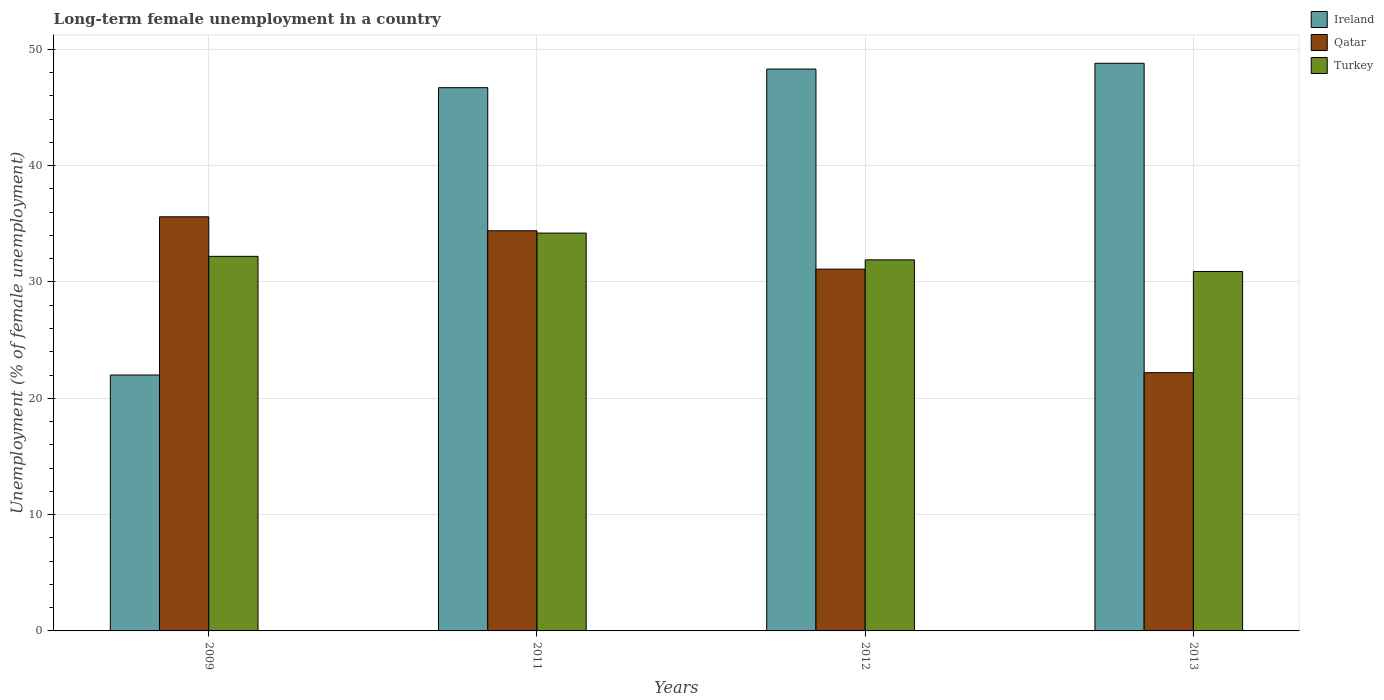How many different coloured bars are there?
Offer a terse response. 3. Are the number of bars on each tick of the X-axis equal?
Ensure brevity in your answer.  Yes. How many bars are there on the 1st tick from the left?
Offer a very short reply. 3. What is the label of the 1st group of bars from the left?
Ensure brevity in your answer.  2009. What is the percentage of long-term unemployed female population in Ireland in 2013?
Offer a very short reply. 48.8. Across all years, what is the maximum percentage of long-term unemployed female population in Qatar?
Ensure brevity in your answer.  35.6. Across all years, what is the minimum percentage of long-term unemployed female population in Qatar?
Offer a very short reply. 22.2. What is the total percentage of long-term unemployed female population in Ireland in the graph?
Offer a very short reply. 165.8. What is the difference between the percentage of long-term unemployed female population in Turkey in 2012 and that in 2013?
Offer a terse response. 1. What is the difference between the percentage of long-term unemployed female population in Turkey in 2009 and the percentage of long-term unemployed female population in Ireland in 2013?
Ensure brevity in your answer.  -16.6. What is the average percentage of long-term unemployed female population in Ireland per year?
Your answer should be compact. 41.45. In the year 2011, what is the difference between the percentage of long-term unemployed female population in Qatar and percentage of long-term unemployed female population in Ireland?
Your answer should be very brief. -12.3. What is the ratio of the percentage of long-term unemployed female population in Ireland in 2012 to that in 2013?
Provide a short and direct response. 0.99. Is the percentage of long-term unemployed female population in Qatar in 2011 less than that in 2013?
Give a very brief answer. No. What is the difference between the highest and the second highest percentage of long-term unemployed female population in Turkey?
Your response must be concise. 2. What is the difference between the highest and the lowest percentage of long-term unemployed female population in Qatar?
Offer a very short reply. 13.4. Is the sum of the percentage of long-term unemployed female population in Qatar in 2011 and 2012 greater than the maximum percentage of long-term unemployed female population in Turkey across all years?
Keep it short and to the point. Yes. What does the 2nd bar from the left in 2011 represents?
Offer a terse response. Qatar. What does the 2nd bar from the right in 2012 represents?
Provide a short and direct response. Qatar. Is it the case that in every year, the sum of the percentage of long-term unemployed female population in Ireland and percentage of long-term unemployed female population in Turkey is greater than the percentage of long-term unemployed female population in Qatar?
Make the answer very short. Yes. How many bars are there?
Provide a succinct answer. 12. What is the difference between two consecutive major ticks on the Y-axis?
Your response must be concise. 10. How many legend labels are there?
Provide a succinct answer. 3. What is the title of the graph?
Your answer should be compact. Long-term female unemployment in a country. What is the label or title of the Y-axis?
Provide a short and direct response. Unemployment (% of female unemployment). What is the Unemployment (% of female unemployment) in Ireland in 2009?
Your answer should be compact. 22. What is the Unemployment (% of female unemployment) of Qatar in 2009?
Offer a very short reply. 35.6. What is the Unemployment (% of female unemployment) of Turkey in 2009?
Make the answer very short. 32.2. What is the Unemployment (% of female unemployment) in Ireland in 2011?
Offer a terse response. 46.7. What is the Unemployment (% of female unemployment) in Qatar in 2011?
Provide a short and direct response. 34.4. What is the Unemployment (% of female unemployment) in Turkey in 2011?
Your response must be concise. 34.2. What is the Unemployment (% of female unemployment) of Ireland in 2012?
Your answer should be compact. 48.3. What is the Unemployment (% of female unemployment) in Qatar in 2012?
Ensure brevity in your answer.  31.1. What is the Unemployment (% of female unemployment) of Turkey in 2012?
Keep it short and to the point. 31.9. What is the Unemployment (% of female unemployment) in Ireland in 2013?
Offer a terse response. 48.8. What is the Unemployment (% of female unemployment) of Qatar in 2013?
Make the answer very short. 22.2. What is the Unemployment (% of female unemployment) in Turkey in 2013?
Ensure brevity in your answer.  30.9. Across all years, what is the maximum Unemployment (% of female unemployment) of Ireland?
Ensure brevity in your answer.  48.8. Across all years, what is the maximum Unemployment (% of female unemployment) of Qatar?
Your answer should be compact. 35.6. Across all years, what is the maximum Unemployment (% of female unemployment) in Turkey?
Give a very brief answer. 34.2. Across all years, what is the minimum Unemployment (% of female unemployment) in Qatar?
Keep it short and to the point. 22.2. Across all years, what is the minimum Unemployment (% of female unemployment) of Turkey?
Offer a very short reply. 30.9. What is the total Unemployment (% of female unemployment) in Ireland in the graph?
Provide a succinct answer. 165.8. What is the total Unemployment (% of female unemployment) in Qatar in the graph?
Offer a very short reply. 123.3. What is the total Unemployment (% of female unemployment) in Turkey in the graph?
Keep it short and to the point. 129.2. What is the difference between the Unemployment (% of female unemployment) of Ireland in 2009 and that in 2011?
Your answer should be compact. -24.7. What is the difference between the Unemployment (% of female unemployment) in Qatar in 2009 and that in 2011?
Your response must be concise. 1.2. What is the difference between the Unemployment (% of female unemployment) of Turkey in 2009 and that in 2011?
Your response must be concise. -2. What is the difference between the Unemployment (% of female unemployment) in Ireland in 2009 and that in 2012?
Keep it short and to the point. -26.3. What is the difference between the Unemployment (% of female unemployment) in Qatar in 2009 and that in 2012?
Offer a terse response. 4.5. What is the difference between the Unemployment (% of female unemployment) in Turkey in 2009 and that in 2012?
Your answer should be very brief. 0.3. What is the difference between the Unemployment (% of female unemployment) of Ireland in 2009 and that in 2013?
Offer a very short reply. -26.8. What is the difference between the Unemployment (% of female unemployment) of Qatar in 2009 and that in 2013?
Provide a succinct answer. 13.4. What is the difference between the Unemployment (% of female unemployment) of Turkey in 2009 and that in 2013?
Provide a short and direct response. 1.3. What is the difference between the Unemployment (% of female unemployment) of Ireland in 2011 and that in 2013?
Keep it short and to the point. -2.1. What is the difference between the Unemployment (% of female unemployment) of Qatar in 2011 and that in 2013?
Your answer should be compact. 12.2. What is the difference between the Unemployment (% of female unemployment) of Ireland in 2012 and that in 2013?
Keep it short and to the point. -0.5. What is the difference between the Unemployment (% of female unemployment) in Ireland in 2009 and the Unemployment (% of female unemployment) in Qatar in 2011?
Make the answer very short. -12.4. What is the difference between the Unemployment (% of female unemployment) of Ireland in 2009 and the Unemployment (% of female unemployment) of Turkey in 2011?
Ensure brevity in your answer.  -12.2. What is the difference between the Unemployment (% of female unemployment) of Ireland in 2009 and the Unemployment (% of female unemployment) of Qatar in 2012?
Your answer should be very brief. -9.1. What is the difference between the Unemployment (% of female unemployment) of Ireland in 2009 and the Unemployment (% of female unemployment) of Turkey in 2012?
Your response must be concise. -9.9. What is the difference between the Unemployment (% of female unemployment) of Qatar in 2009 and the Unemployment (% of female unemployment) of Turkey in 2012?
Your answer should be very brief. 3.7. What is the difference between the Unemployment (% of female unemployment) of Ireland in 2009 and the Unemployment (% of female unemployment) of Turkey in 2013?
Make the answer very short. -8.9. What is the difference between the Unemployment (% of female unemployment) in Qatar in 2011 and the Unemployment (% of female unemployment) in Turkey in 2012?
Provide a short and direct response. 2.5. What is the difference between the Unemployment (% of female unemployment) in Ireland in 2011 and the Unemployment (% of female unemployment) in Qatar in 2013?
Make the answer very short. 24.5. What is the difference between the Unemployment (% of female unemployment) of Qatar in 2011 and the Unemployment (% of female unemployment) of Turkey in 2013?
Your response must be concise. 3.5. What is the difference between the Unemployment (% of female unemployment) of Ireland in 2012 and the Unemployment (% of female unemployment) of Qatar in 2013?
Ensure brevity in your answer.  26.1. What is the difference between the Unemployment (% of female unemployment) in Qatar in 2012 and the Unemployment (% of female unemployment) in Turkey in 2013?
Keep it short and to the point. 0.2. What is the average Unemployment (% of female unemployment) of Ireland per year?
Ensure brevity in your answer.  41.45. What is the average Unemployment (% of female unemployment) in Qatar per year?
Give a very brief answer. 30.82. What is the average Unemployment (% of female unemployment) in Turkey per year?
Your response must be concise. 32.3. In the year 2009, what is the difference between the Unemployment (% of female unemployment) in Ireland and Unemployment (% of female unemployment) in Qatar?
Provide a succinct answer. -13.6. In the year 2009, what is the difference between the Unemployment (% of female unemployment) in Ireland and Unemployment (% of female unemployment) in Turkey?
Offer a terse response. -10.2. In the year 2011, what is the difference between the Unemployment (% of female unemployment) in Ireland and Unemployment (% of female unemployment) in Qatar?
Give a very brief answer. 12.3. In the year 2011, what is the difference between the Unemployment (% of female unemployment) in Ireland and Unemployment (% of female unemployment) in Turkey?
Your answer should be compact. 12.5. In the year 2013, what is the difference between the Unemployment (% of female unemployment) in Ireland and Unemployment (% of female unemployment) in Qatar?
Give a very brief answer. 26.6. In the year 2013, what is the difference between the Unemployment (% of female unemployment) in Ireland and Unemployment (% of female unemployment) in Turkey?
Make the answer very short. 17.9. In the year 2013, what is the difference between the Unemployment (% of female unemployment) of Qatar and Unemployment (% of female unemployment) of Turkey?
Keep it short and to the point. -8.7. What is the ratio of the Unemployment (% of female unemployment) of Ireland in 2009 to that in 2011?
Offer a very short reply. 0.47. What is the ratio of the Unemployment (% of female unemployment) of Qatar in 2009 to that in 2011?
Keep it short and to the point. 1.03. What is the ratio of the Unemployment (% of female unemployment) in Turkey in 2009 to that in 2011?
Ensure brevity in your answer.  0.94. What is the ratio of the Unemployment (% of female unemployment) in Ireland in 2009 to that in 2012?
Offer a very short reply. 0.46. What is the ratio of the Unemployment (% of female unemployment) in Qatar in 2009 to that in 2012?
Give a very brief answer. 1.14. What is the ratio of the Unemployment (% of female unemployment) of Turkey in 2009 to that in 2012?
Make the answer very short. 1.01. What is the ratio of the Unemployment (% of female unemployment) in Ireland in 2009 to that in 2013?
Offer a very short reply. 0.45. What is the ratio of the Unemployment (% of female unemployment) in Qatar in 2009 to that in 2013?
Keep it short and to the point. 1.6. What is the ratio of the Unemployment (% of female unemployment) of Turkey in 2009 to that in 2013?
Provide a short and direct response. 1.04. What is the ratio of the Unemployment (% of female unemployment) of Ireland in 2011 to that in 2012?
Keep it short and to the point. 0.97. What is the ratio of the Unemployment (% of female unemployment) in Qatar in 2011 to that in 2012?
Your answer should be compact. 1.11. What is the ratio of the Unemployment (% of female unemployment) in Turkey in 2011 to that in 2012?
Provide a succinct answer. 1.07. What is the ratio of the Unemployment (% of female unemployment) in Qatar in 2011 to that in 2013?
Offer a very short reply. 1.55. What is the ratio of the Unemployment (% of female unemployment) of Turkey in 2011 to that in 2013?
Provide a short and direct response. 1.11. What is the ratio of the Unemployment (% of female unemployment) in Qatar in 2012 to that in 2013?
Your answer should be very brief. 1.4. What is the ratio of the Unemployment (% of female unemployment) in Turkey in 2012 to that in 2013?
Ensure brevity in your answer.  1.03. What is the difference between the highest and the lowest Unemployment (% of female unemployment) of Ireland?
Provide a succinct answer. 26.8. What is the difference between the highest and the lowest Unemployment (% of female unemployment) of Turkey?
Keep it short and to the point. 3.3. 